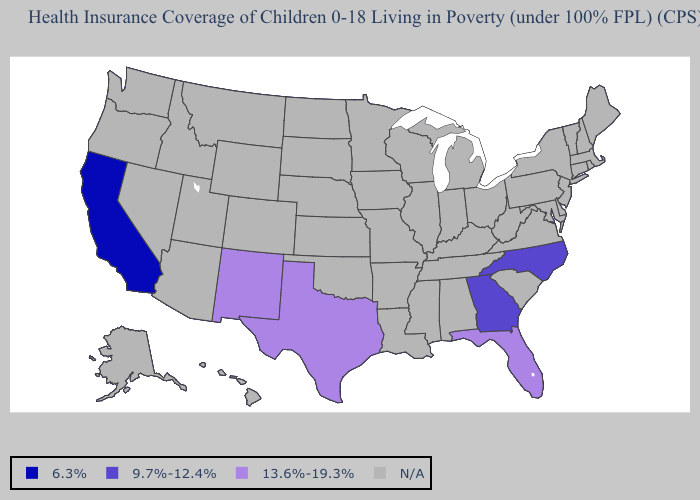Among the states that border Louisiana , which have the highest value?
Answer briefly. Texas. Is the legend a continuous bar?
Give a very brief answer. No. What is the value of Tennessee?
Be succinct. N/A. What is the lowest value in the West?
Answer briefly. 6.3%. Name the states that have a value in the range 13.6%-19.3%?
Concise answer only. Florida, New Mexico, Texas. Name the states that have a value in the range 9.7%-12.4%?
Write a very short answer. Georgia, North Carolina. Which states have the lowest value in the West?
Keep it brief. California. Does North Carolina have the lowest value in the USA?
Give a very brief answer. No. Does North Carolina have the lowest value in the USA?
Answer briefly. No. What is the value of Connecticut?
Be succinct. N/A. 